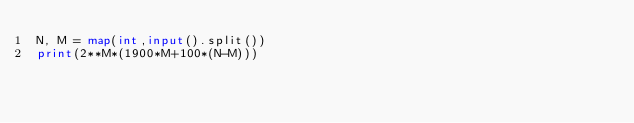<code> <loc_0><loc_0><loc_500><loc_500><_Python_>N, M = map(int,input().split())
print(2**M*(1900*M+100*(N-M)))</code> 